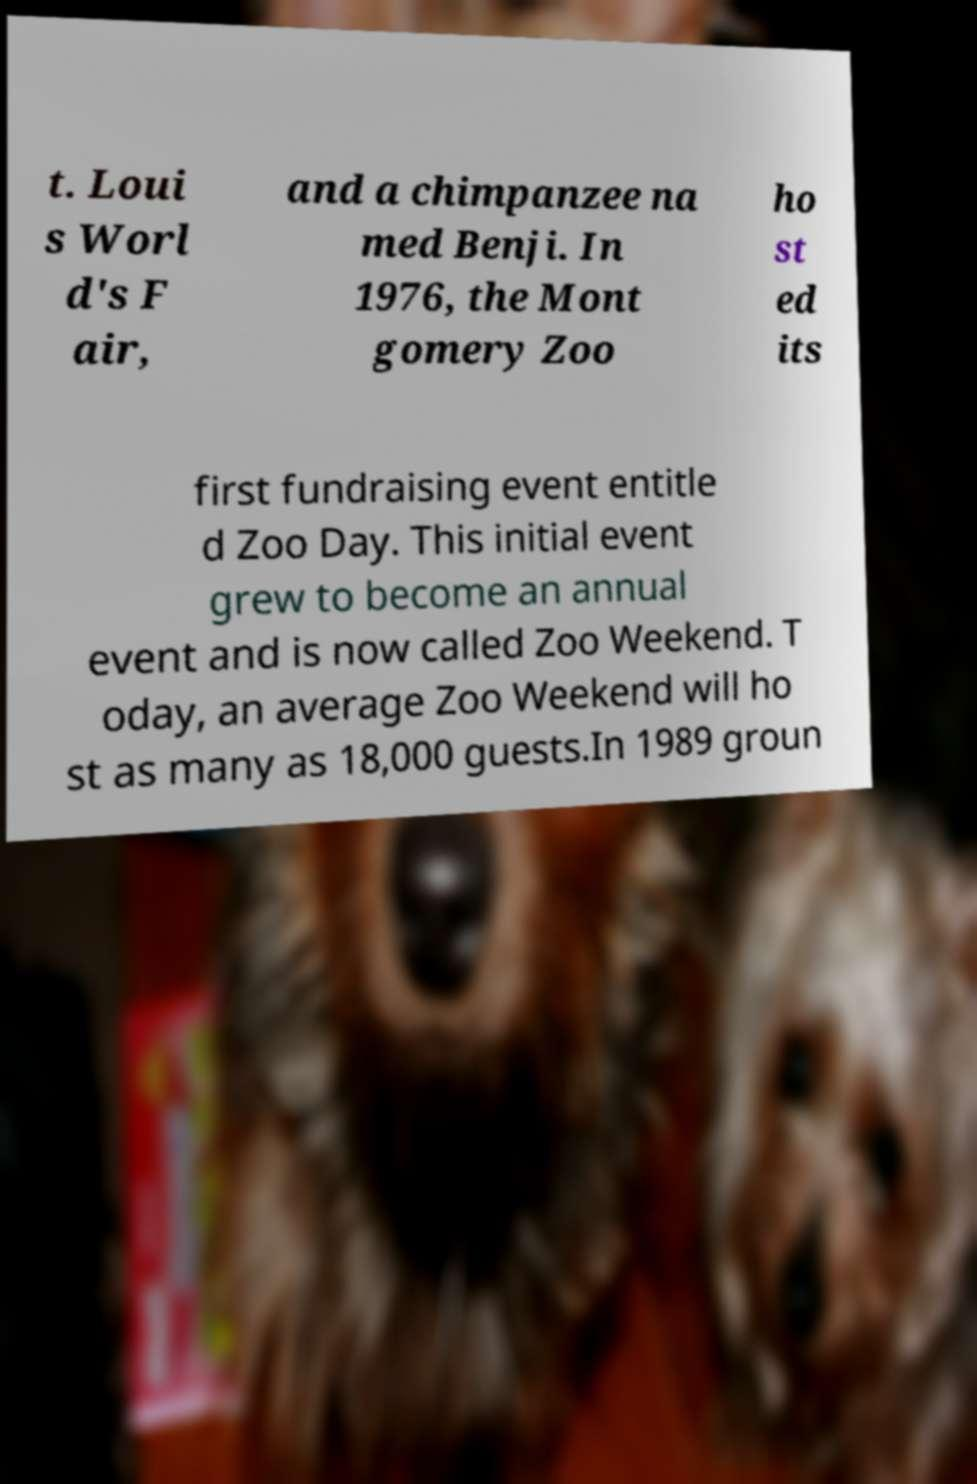What messages or text are displayed in this image? I need them in a readable, typed format. t. Loui s Worl d's F air, and a chimpanzee na med Benji. In 1976, the Mont gomery Zoo ho st ed its first fundraising event entitle d Zoo Day. This initial event grew to become an annual event and is now called Zoo Weekend. T oday, an average Zoo Weekend will ho st as many as 18,000 guests.In 1989 groun 